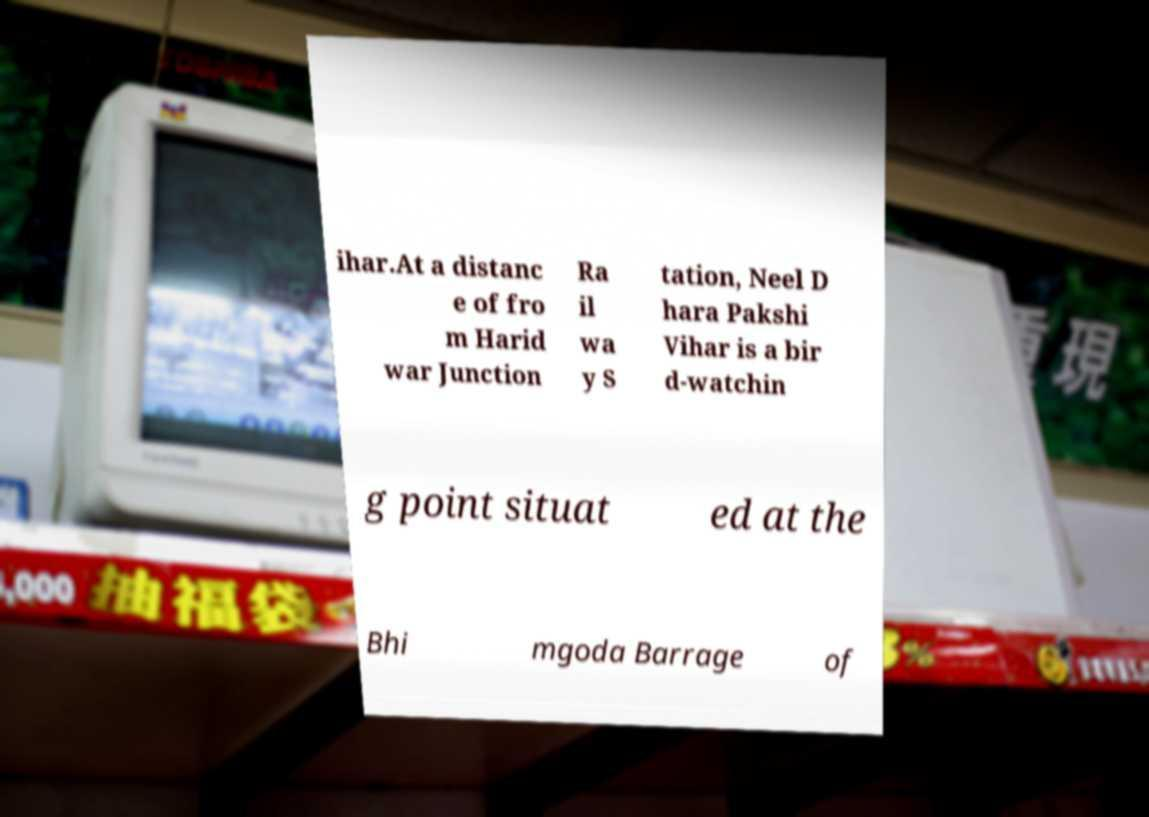I need the written content from this picture converted into text. Can you do that? ihar.At a distanc e of fro m Harid war Junction Ra il wa y S tation, Neel D hara Pakshi Vihar is a bir d-watchin g point situat ed at the Bhi mgoda Barrage of 